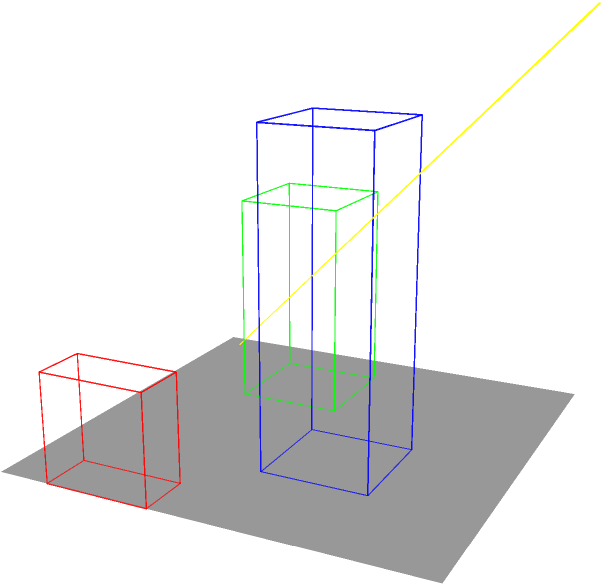In the urban layout shown, three buildings of different heights are positioned on a flat surface. The yellow arrow represents the direction of sunlight. Which building should be relocated to minimize its shadow impact on the other structures while maintaining maximum sunlight exposure for all buildings? To solve this problem, we need to analyze the position and height of each building in relation to the sunlight direction:

1. The blue building is the tallest (3 units high) and is positioned in the center.
2. The green building is medium height (2 units high) and is in the back-left corner.
3. The red building is the shortest (1 unit high) and is in the front-right corner.
4. The sunlight is coming from the top-right direction.

Step-by-step analysis:
1. The blue building, being the tallest, will cast the longest shadow. Its central position means it could potentially shade both other buildings.
2. The green building is in a good position as it's in the back-left, opposite the sunlight direction. It's unlikely to cast shadows on the other buildings.
3. The red building, despite being the shortest, is poorly positioned. It's directly in the path of sunlight to the other buildings.

To maximize sunlight exposure for all buildings:
- The blue building should stay central due to its height.
- The green building is already well-positioned.
- The red building should be relocated to minimize its interference with sunlight reaching the other buildings.

The optimal solution is to move the red building to the front-left corner. This way, it won't obstruct sunlight to the taller buildings, and all structures will receive maximum sun exposure.
Answer: Red building 